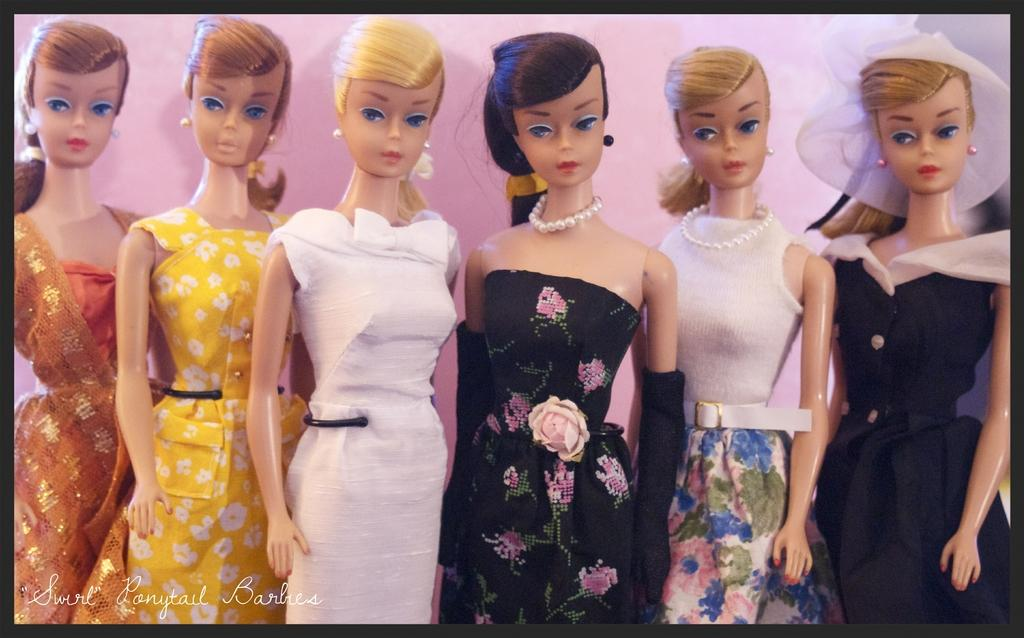What type of toys are in the image? There are barbie dolls in the image. How are the barbie dolls dressed? The barbie dolls are wearing different color dresses. What color is the background of the image? The background of the image is pink. What type of fruit can be seen in the image? There is no fruit present in the image; it features barbie dolls wearing different color dresses against a pink background. 